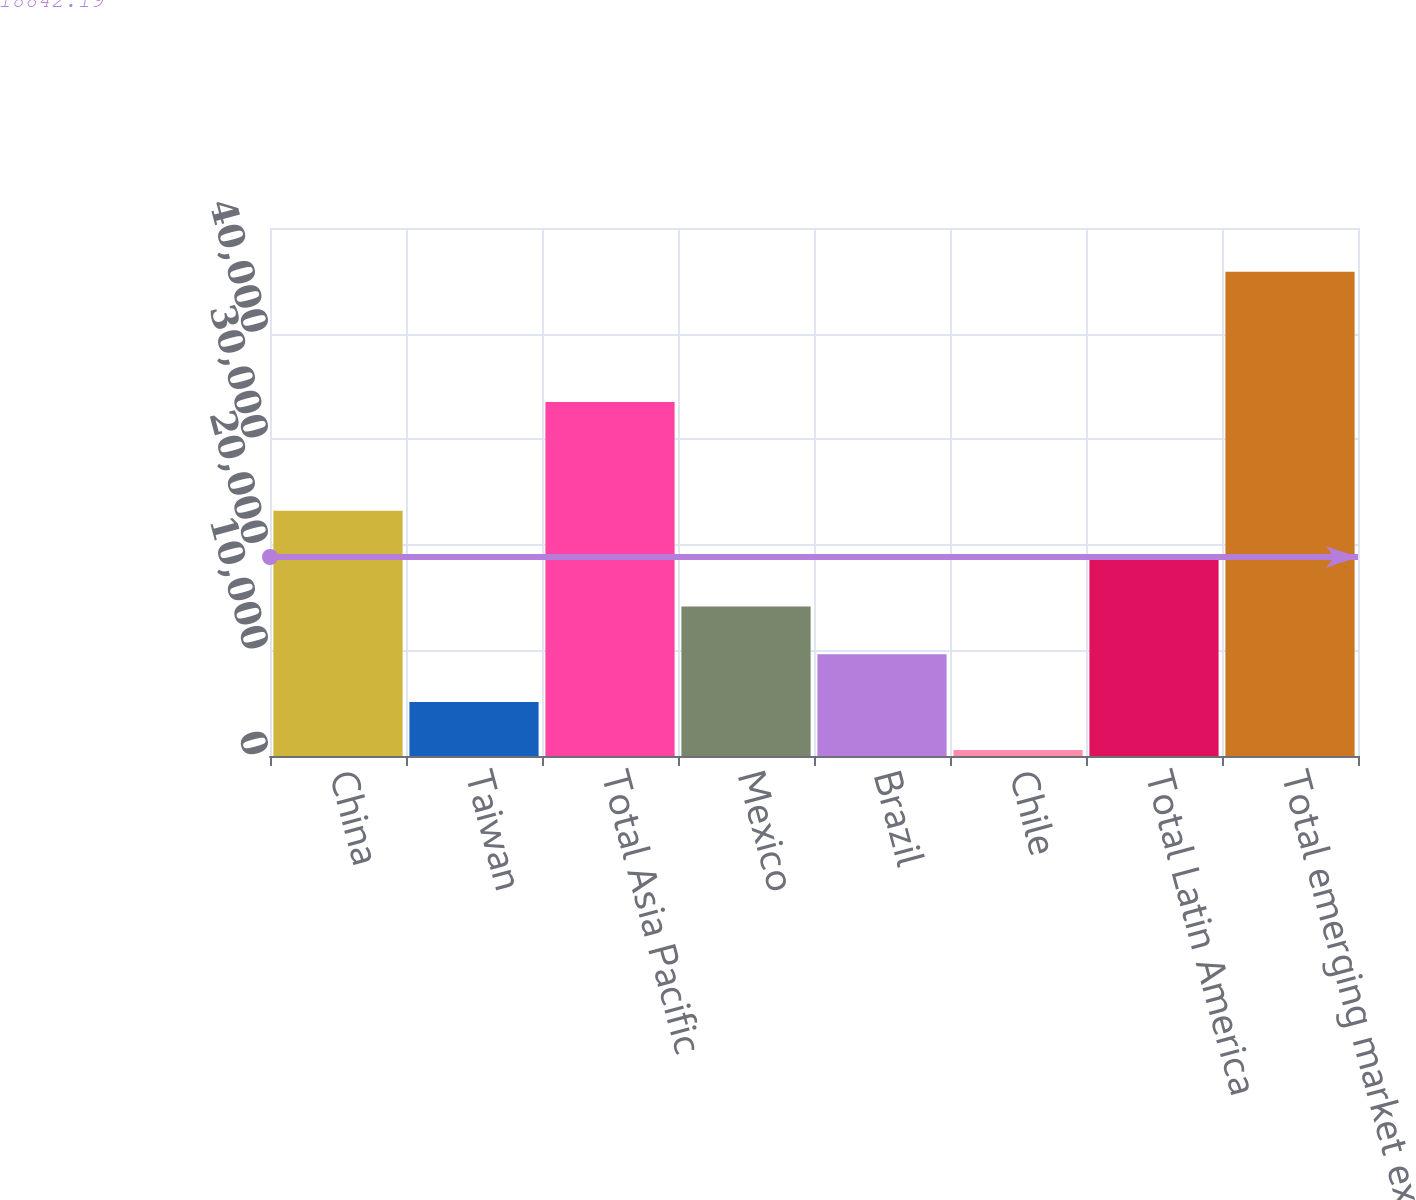Convert chart to OTSL. <chart><loc_0><loc_0><loc_500><loc_500><bar_chart><fcel>China<fcel>Taiwan<fcel>Total Asia Pacific<fcel>Mexico<fcel>Brazil<fcel>Chile<fcel>Total Latin America<fcel>Total emerging market exposure<nl><fcel>23213.5<fcel>5105.9<fcel>33512<fcel>14159.7<fcel>9632.8<fcel>579<fcel>18686.6<fcel>45848<nl></chart> 